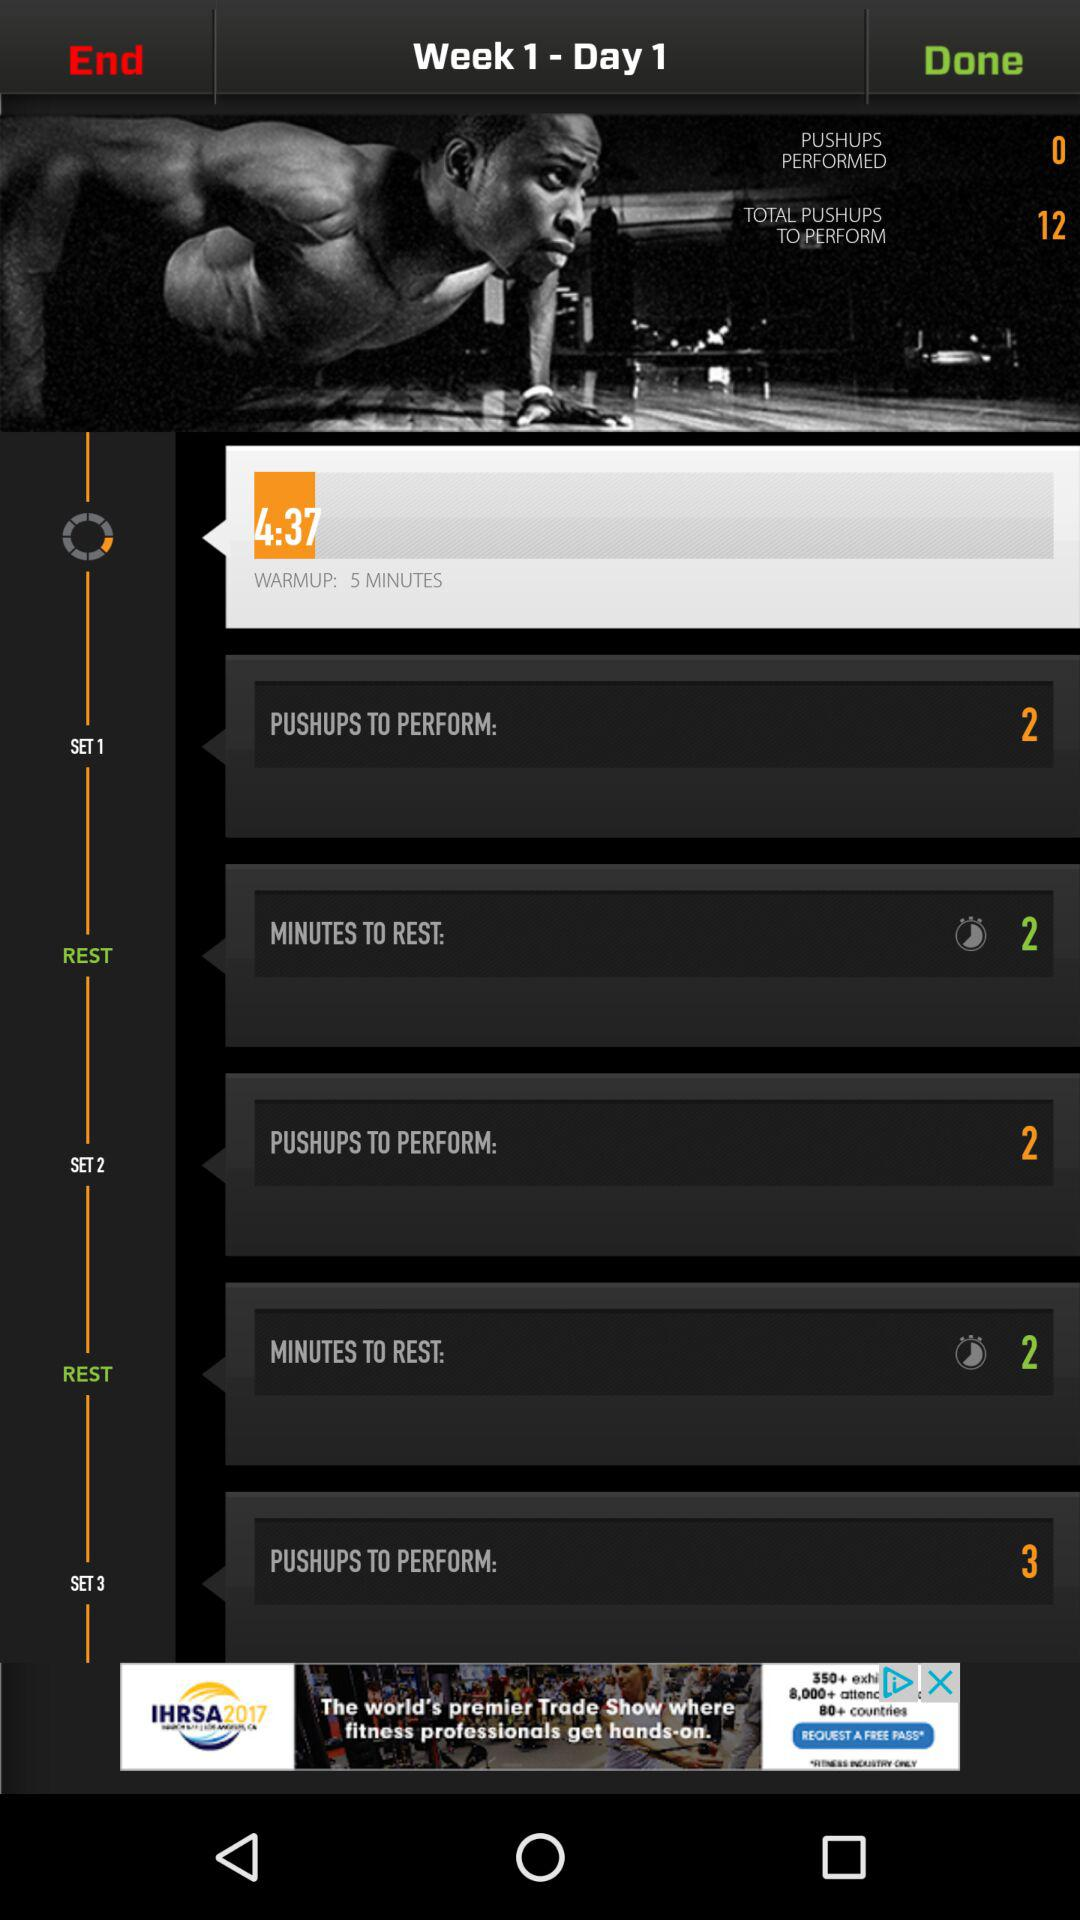How long do I need to rest before my next set?
Answer the question using a single word or phrase. 2 minutes 